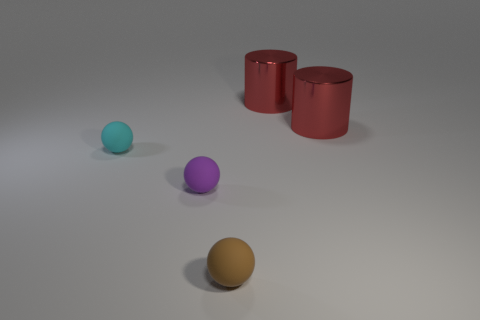Subtract all tiny purple matte balls. How many balls are left? 2 Add 5 tiny purple metal cylinders. How many objects exist? 10 Subtract all spheres. How many objects are left? 2 Subtract all purple cylinders. Subtract all yellow cubes. How many cylinders are left? 2 Add 1 small brown balls. How many small brown balls are left? 2 Add 3 yellow metal balls. How many yellow metal balls exist? 3 Subtract 0 brown cubes. How many objects are left? 5 Subtract 2 spheres. How many spheres are left? 1 Subtract all purple matte objects. Subtract all cyan cylinders. How many objects are left? 4 